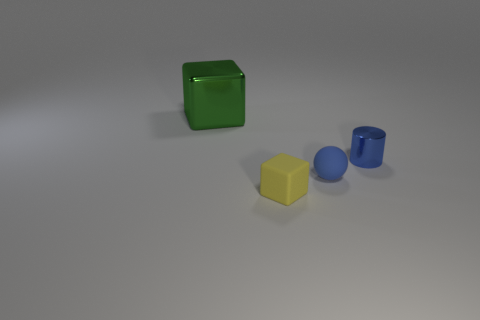Subtract all cylinders. How many objects are left? 3 Subtract all green blocks. How many blocks are left? 1 Add 3 small rubber cubes. How many objects exist? 7 Subtract 1 blocks. How many blocks are left? 1 Subtract all large green rubber cylinders. Subtract all tiny rubber spheres. How many objects are left? 3 Add 4 big green metallic cubes. How many big green metallic cubes are left? 5 Add 1 brown metal spheres. How many brown metal spheres exist? 1 Subtract 0 yellow cylinders. How many objects are left? 4 Subtract all yellow spheres. Subtract all yellow cubes. How many spheres are left? 1 Subtract all green blocks. How many purple cylinders are left? 0 